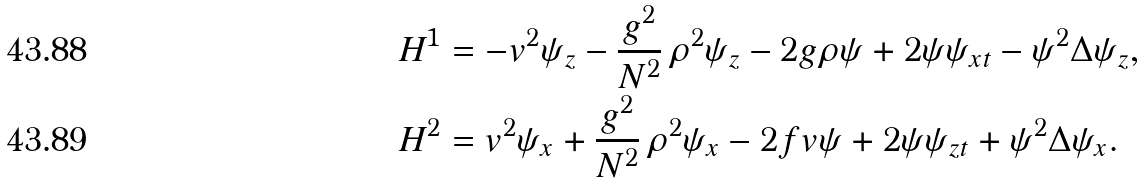Convert formula to latex. <formula><loc_0><loc_0><loc_500><loc_500>& H ^ { 1 } = - v ^ { 2 } \psi _ { z } - \frac { g ^ { 2 } } { N ^ { 2 } } \, \rho ^ { 2 } \psi _ { z } - 2 g \rho \psi + 2 \psi \psi _ { x t } - \psi ^ { 2 } \Delta \psi _ { z } , \\ & H ^ { 2 } = v ^ { 2 } \psi _ { x } + \frac { g ^ { 2 } } { N ^ { 2 } } \, \rho ^ { 2 } \psi _ { x } - 2 f v \psi + 2 \psi \psi _ { z t } + \psi ^ { 2 } \Delta \psi _ { x } .</formula> 